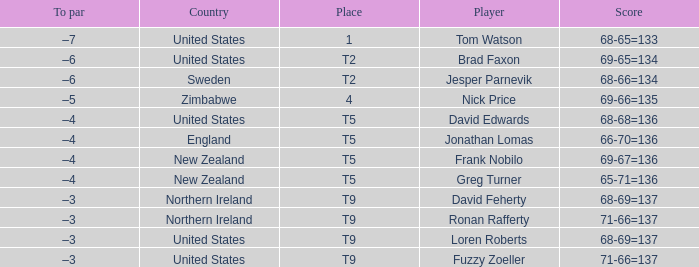The golfer in place 1 if from what country? United States. Can you give me this table as a dict? {'header': ['To par', 'Country', 'Place', 'Player', 'Score'], 'rows': [['–7', 'United States', '1', 'Tom Watson', '68-65=133'], ['–6', 'United States', 'T2', 'Brad Faxon', '69-65=134'], ['–6', 'Sweden', 'T2', 'Jesper Parnevik', '68-66=134'], ['–5', 'Zimbabwe', '4', 'Nick Price', '69-66=135'], ['–4', 'United States', 'T5', 'David Edwards', '68-68=136'], ['–4', 'England', 'T5', 'Jonathan Lomas', '66-70=136'], ['–4', 'New Zealand', 'T5', 'Frank Nobilo', '69-67=136'], ['–4', 'New Zealand', 'T5', 'Greg Turner', '65-71=136'], ['–3', 'Northern Ireland', 'T9', 'David Feherty', '68-69=137'], ['–3', 'Northern Ireland', 'T9', 'Ronan Rafferty', '71-66=137'], ['–3', 'United States', 'T9', 'Loren Roberts', '68-69=137'], ['–3', 'United States', 'T9', 'Fuzzy Zoeller', '71-66=137']]} 